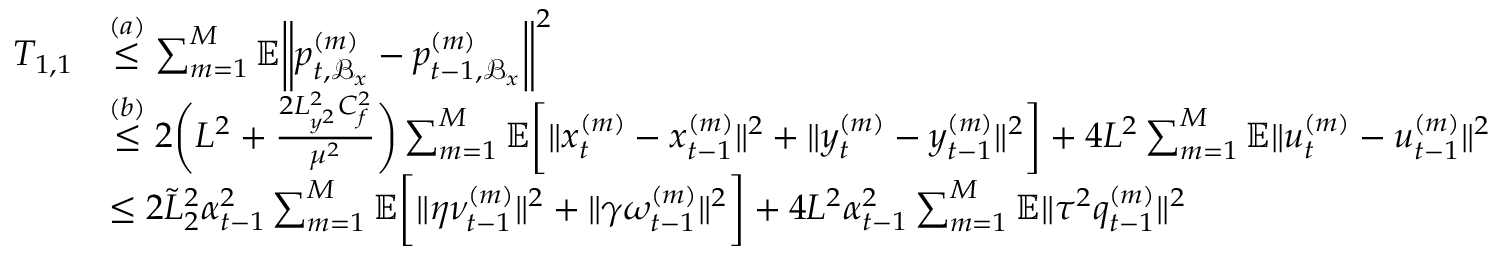<formula> <loc_0><loc_0><loc_500><loc_500>\begin{array} { r l } { T _ { 1 , 1 } } & { \overset { ( a ) } { \leq } \sum _ { m = 1 } ^ { M } \mathbb { E } \left \| p _ { t , \mathcal { B } _ { x } } ^ { ( m ) } - p _ { t - 1 , \mathcal { B } _ { x } } ^ { ( m ) } \right \| ^ { 2 } } \\ & { \overset { ( b ) } { \leq } 2 \left ( L ^ { 2 } + \frac { 2 L _ { y ^ { 2 } } ^ { 2 } C _ { f } ^ { 2 } } { \mu ^ { 2 } } \right ) \sum _ { m = 1 } ^ { M } \mathbb { E } \left [ \| x _ { t } ^ { ( m ) } - x _ { t - 1 } ^ { ( m ) } \| ^ { 2 } + \| y _ { t } ^ { ( m ) } - y _ { t - 1 } ^ { ( m ) } \| ^ { 2 } \right ] + 4 L ^ { 2 } \sum _ { m = 1 } ^ { M } \mathbb { E } \| u _ { t } ^ { ( m ) } - u _ { t - 1 } ^ { ( m ) } \| ^ { 2 } } \\ & { \leq 2 \tilde { L } _ { 2 } ^ { 2 } \alpha _ { t - 1 } ^ { 2 } \sum _ { m = 1 } ^ { M } \mathbb { E } \left [ \| \eta \nu _ { t - 1 } ^ { ( m ) } \| ^ { 2 } + \| \gamma \omega _ { t - 1 } ^ { ( m ) } \| ^ { 2 } \right ] + 4 L ^ { 2 } \alpha _ { t - 1 } ^ { 2 } \sum _ { m = 1 } ^ { M } \mathbb { E } \| \tau ^ { 2 } q _ { t - 1 } ^ { ( m ) } \| ^ { 2 } } \end{array}</formula> 